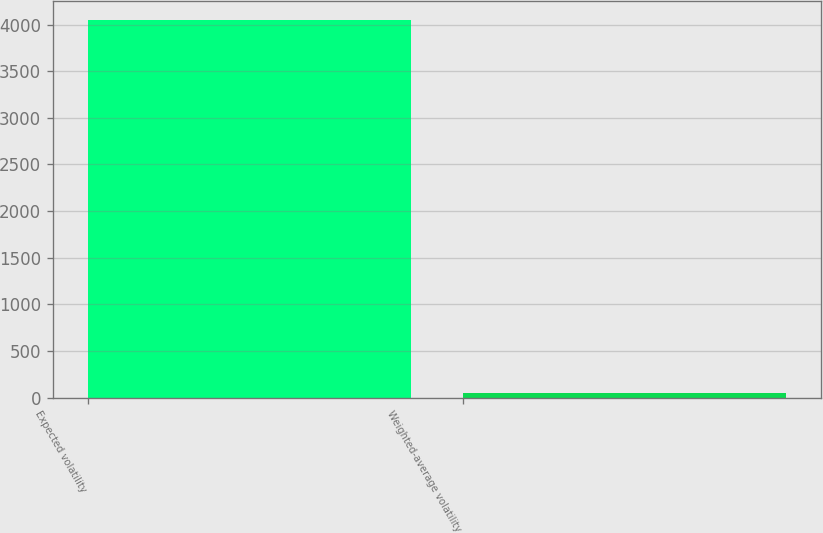Convert chart. <chart><loc_0><loc_0><loc_500><loc_500><bar_chart><fcel>Expected volatility<fcel>Weighted-average volatility<nl><fcel>4048<fcel>45<nl></chart> 